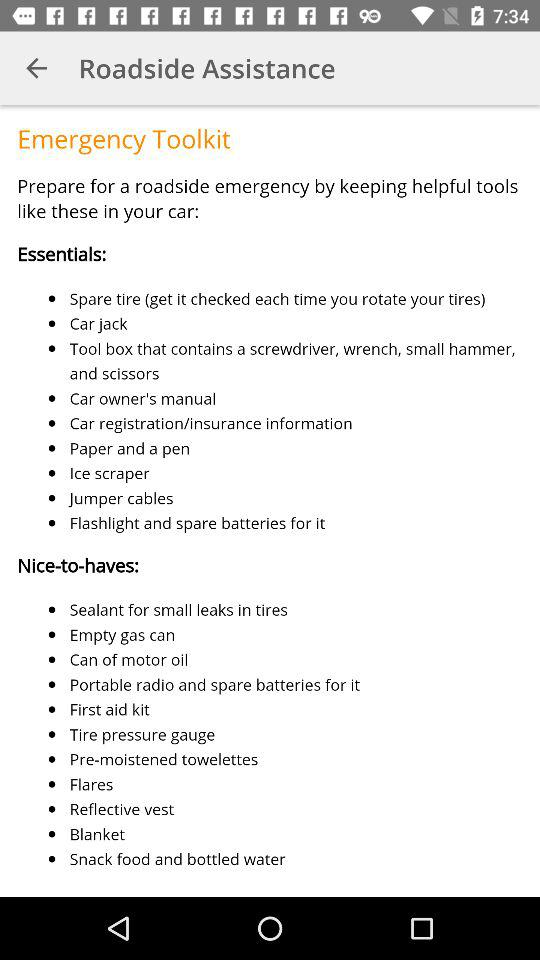What are the nice-to-have features in a car? The nice-to-have features are "Sealant for small leaks in tires", "Empty gas can", "Can of motor oil", "Portable radio and spare batteries for it", "First aid kit", "Tire pressure gauge", "Pre-moistened towelettes", "Flares", "Reflective vest", "Blanket" and "Snack food and bottled water". 